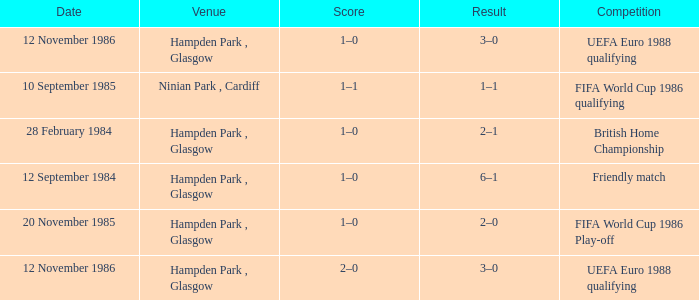What is the Score of the Fifa World Cup 1986 Play-off Competition? 1–0. 